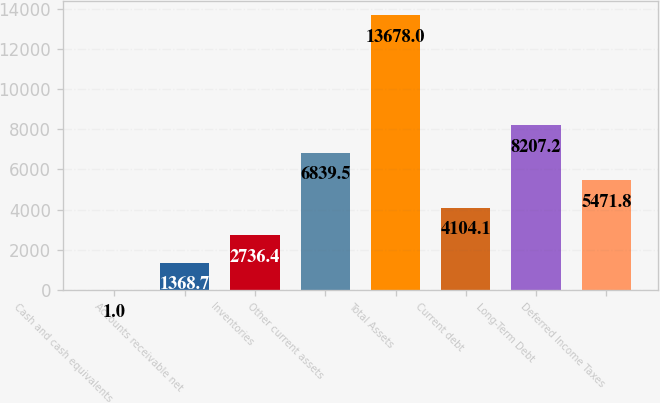Convert chart to OTSL. <chart><loc_0><loc_0><loc_500><loc_500><bar_chart><fcel>Cash and cash equivalents<fcel>Accounts receivable net<fcel>Inventories<fcel>Other current assets<fcel>Total Assets<fcel>Current debt<fcel>Long-Term Debt<fcel>Deferred Income Taxes<nl><fcel>1<fcel>1368.7<fcel>2736.4<fcel>6839.5<fcel>13678<fcel>4104.1<fcel>8207.2<fcel>5471.8<nl></chart> 